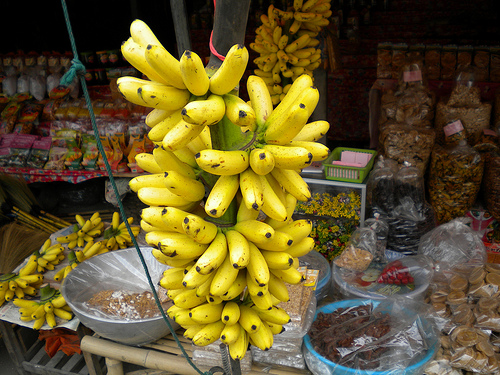Please provide a short description for this region: [0.51, 0.4, 0.62, 0.46]. A ripe yellow banana. Please provide a short description for this region: [0.54, 0.45, 0.62, 0.53]. A ripe yellow banana. Please provide the bounding box coordinate of the region this sentence describes: a round blue bowl. [0.61, 0.72, 0.88, 0.87] Please provide a short description for this region: [0.85, 0.65, 0.99, 0.87]. Bags of cookies. Please provide a short description for this region: [0.64, 0.41, 0.76, 0.49]. A green rectangular basket. Please provide a short description for this region: [0.12, 0.6, 0.41, 0.83]. Spices inside a bowl. Please provide a short description for this region: [0.41, 0.47, 0.47, 0.56]. A ripe yellow banana. Please provide a short description for this region: [0.15, 0.78, 0.6, 0.87]. A wooden table. Please provide the bounding box coordinate of the region this sentence describes: bananas hanged on a stick. [0.49, 0.13, 0.68, 0.32] Please provide the bounding box coordinate of the region this sentence describes: a ripe yellow banana. [0.52, 0.33, 0.61, 0.41] 